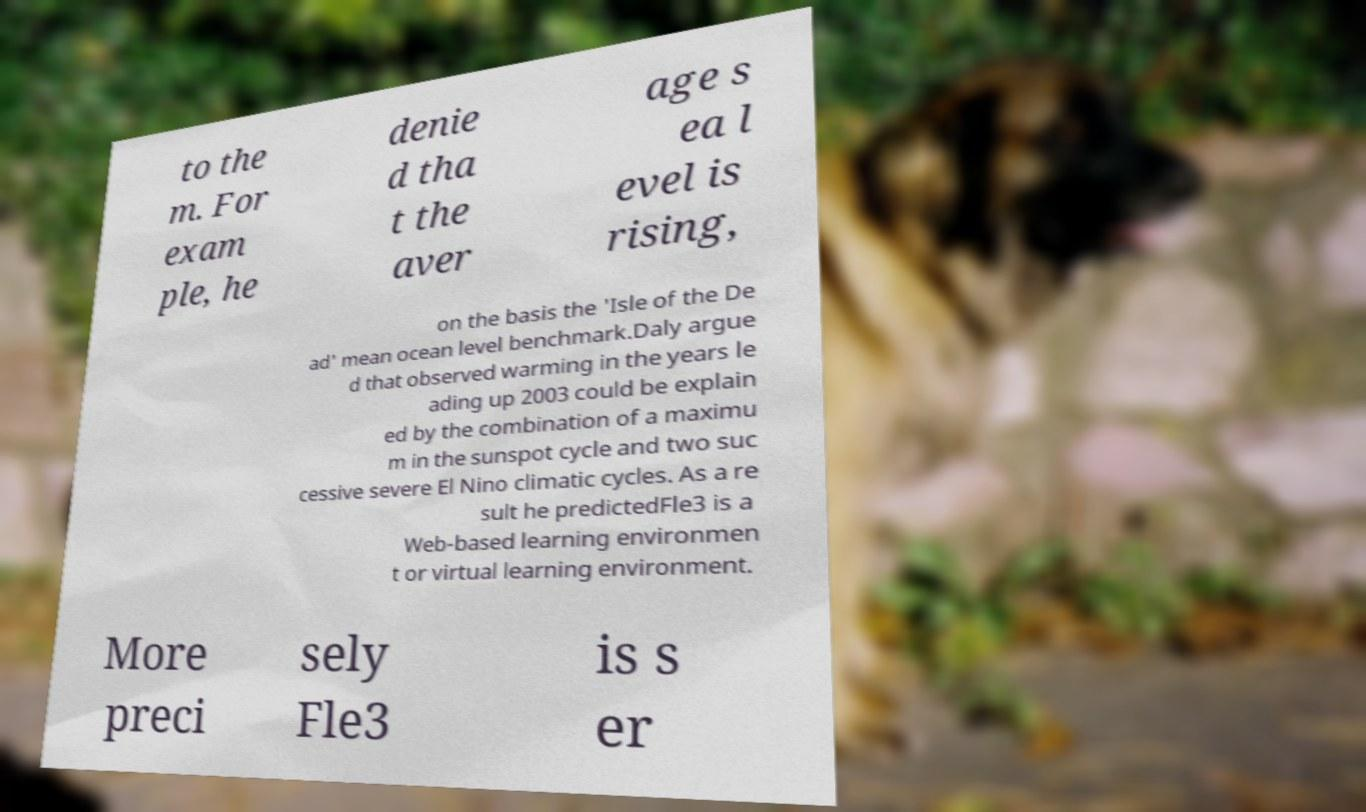Please identify and transcribe the text found in this image. to the m. For exam ple, he denie d tha t the aver age s ea l evel is rising, on the basis the 'Isle of the De ad' mean ocean level benchmark.Daly argue d that observed warming in the years le ading up 2003 could be explain ed by the combination of a maximu m in the sunspot cycle and two suc cessive severe El Nino climatic cycles. As a re sult he predictedFle3 is a Web-based learning environmen t or virtual learning environment. More preci sely Fle3 is s er 